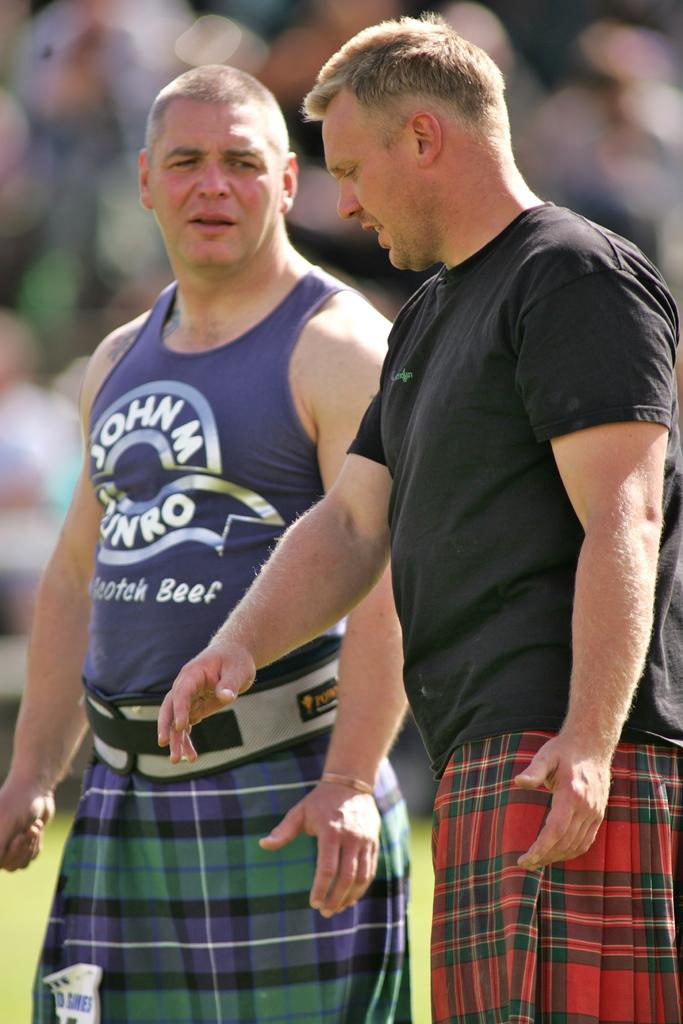How would you summarize this image in a sentence or two? In this image I can see two people standing and talking to each other with a blurred background.  